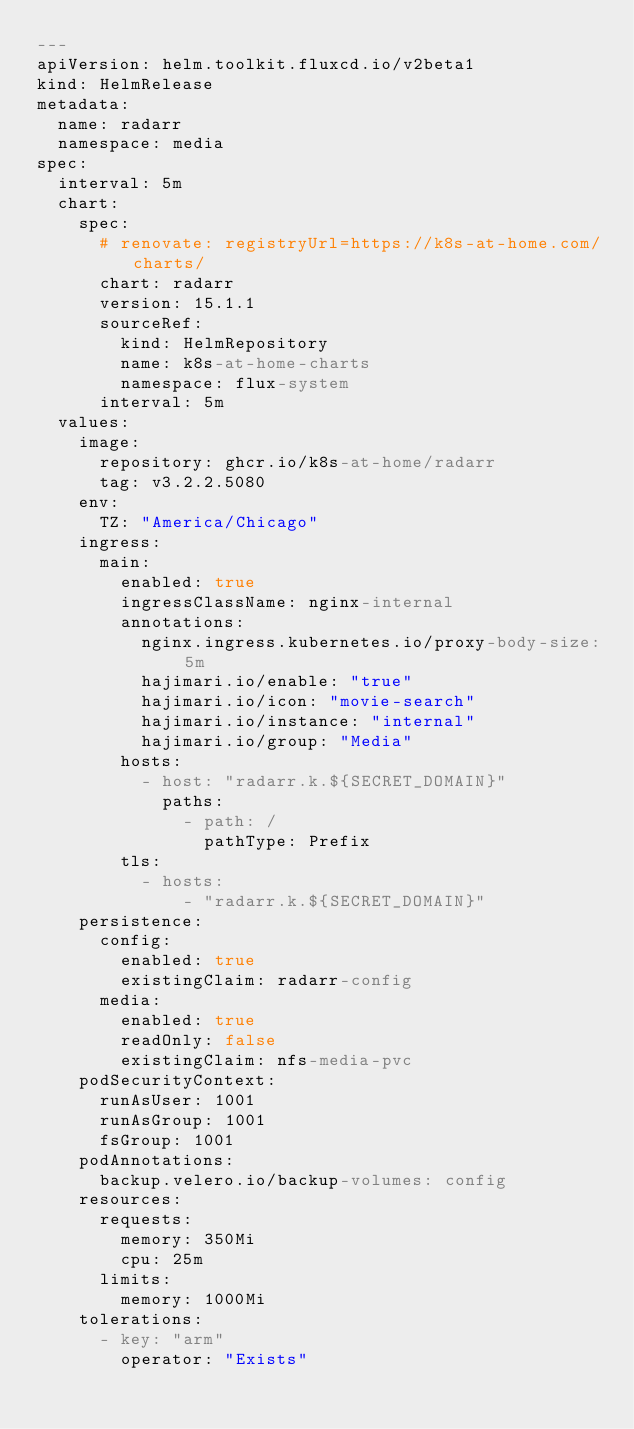<code> <loc_0><loc_0><loc_500><loc_500><_YAML_>---
apiVersion: helm.toolkit.fluxcd.io/v2beta1
kind: HelmRelease
metadata:
  name: radarr
  namespace: media
spec:
  interval: 5m
  chart:
    spec:
      # renovate: registryUrl=https://k8s-at-home.com/charts/
      chart: radarr
      version: 15.1.1
      sourceRef:
        kind: HelmRepository
        name: k8s-at-home-charts
        namespace: flux-system
      interval: 5m
  values:
    image:
      repository: ghcr.io/k8s-at-home/radarr
      tag: v3.2.2.5080
    env:
      TZ: "America/Chicago"
    ingress:
      main:
        enabled: true
        ingressClassName: nginx-internal
        annotations:
          nginx.ingress.kubernetes.io/proxy-body-size: 5m
          hajimari.io/enable: "true"
          hajimari.io/icon: "movie-search"
          hajimari.io/instance: "internal"
          hajimari.io/group: "Media"
        hosts:
          - host: "radarr.k.${SECRET_DOMAIN}"
            paths:
              - path: /
                pathType: Prefix
        tls:
          - hosts:
              - "radarr.k.${SECRET_DOMAIN}"
    persistence:
      config:
        enabled: true
        existingClaim: radarr-config
      media:
        enabled: true
        readOnly: false
        existingClaim: nfs-media-pvc
    podSecurityContext:
      runAsUser: 1001
      runAsGroup: 1001
      fsGroup: 1001
    podAnnotations:
      backup.velero.io/backup-volumes: config
    resources:
      requests:
        memory: 350Mi
        cpu: 25m
      limits:
        memory: 1000Mi
    tolerations:
      - key: "arm"
        operator: "Exists"
</code> 